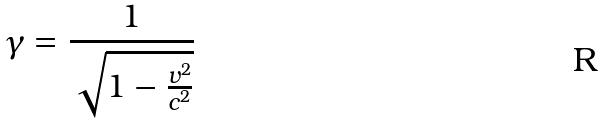<formula> <loc_0><loc_0><loc_500><loc_500>\gamma = \frac { 1 } { \sqrt { 1 - \frac { v ^ { 2 } } { c ^ { 2 } } } }</formula> 